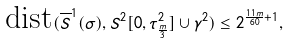<formula> <loc_0><loc_0><loc_500><loc_500>\text {dist} ( \overline { S } ^ { 1 } ( \sigma ) , S ^ { 2 } [ 0 , \tau ^ { 2 } _ { \frac { m } { 3 } } ] \cup \gamma ^ { 2 } ) \leq 2 ^ { \frac { 1 1 m } { 6 0 } + 1 } ,</formula> 